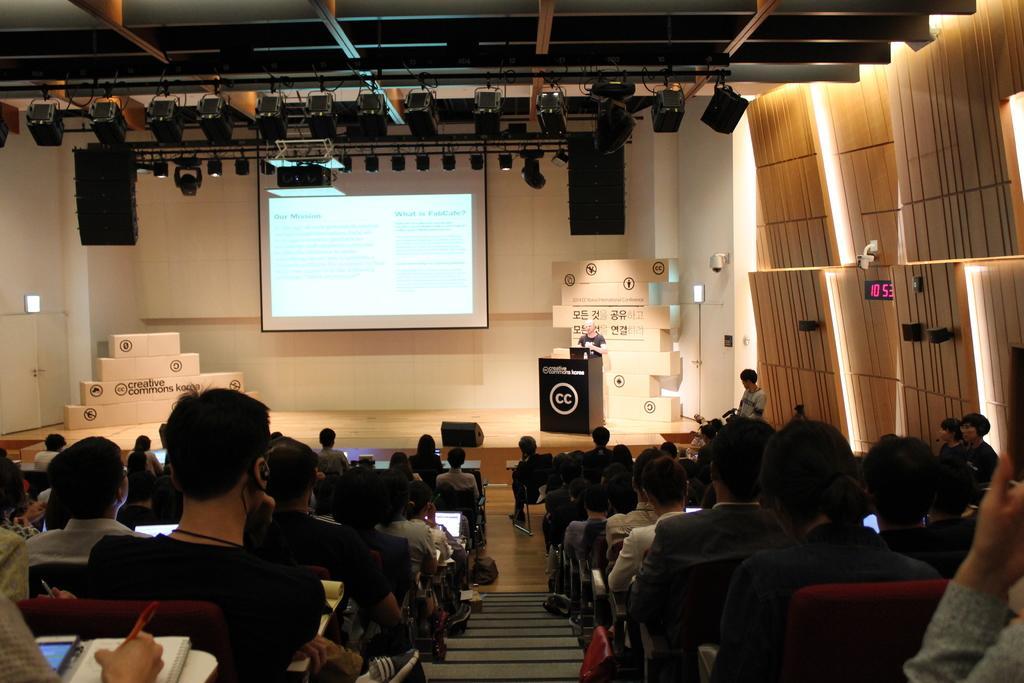Could you give a brief overview of what you see in this image? In this image I can see group of people sitting and holding few pens and books. Background I can see a person standing holding a camera, in front I can see a person standing in front of the podium. Background I can see a projector screen and the wall is in white color. 